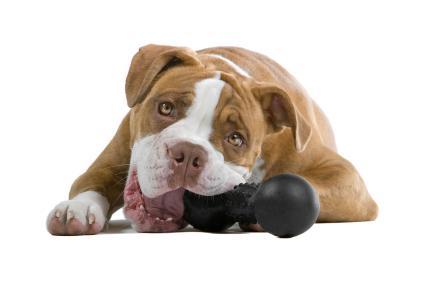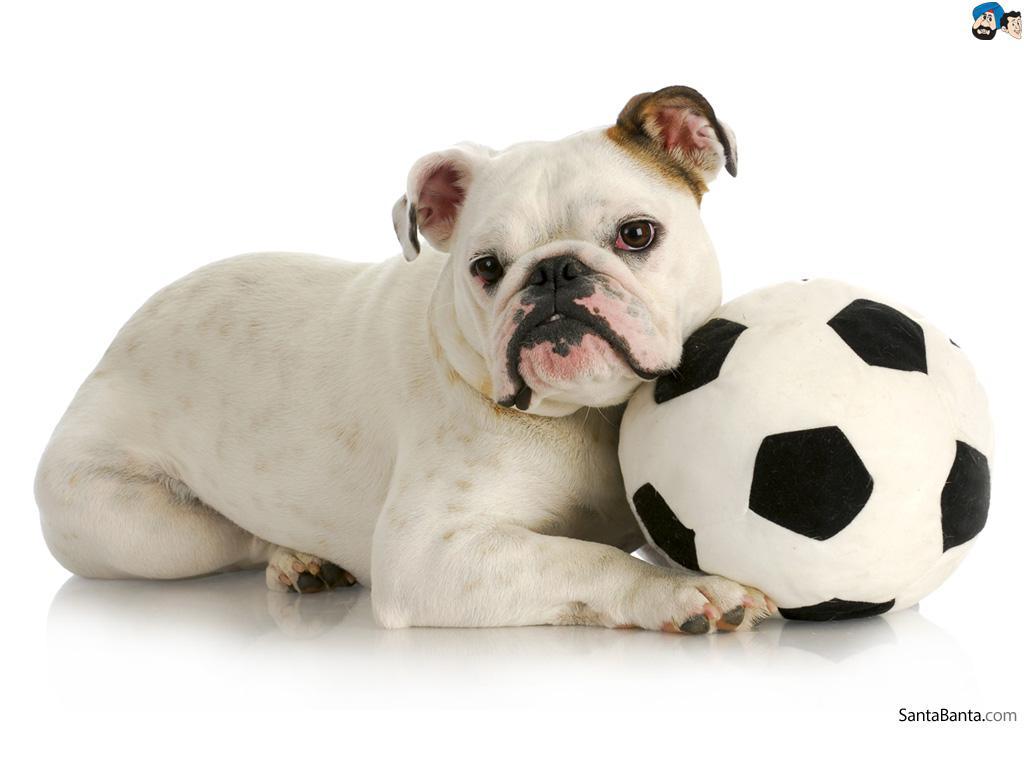The first image is the image on the left, the second image is the image on the right. Analyze the images presented: Is the assertion "Each image features one bulldog posed with something in front of its face, and the dog on the left is gnawing on something." valid? Answer yes or no. Yes. The first image is the image on the left, the second image is the image on the right. For the images shown, is this caption "One of the images features a dog chewing an object." true? Answer yes or no. Yes. 